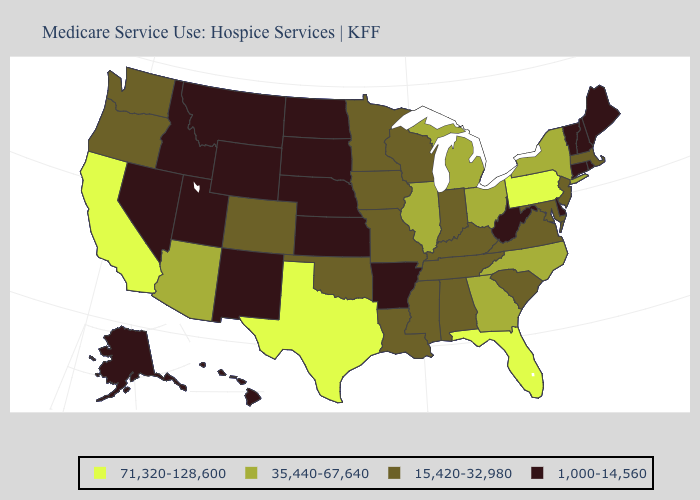Name the states that have a value in the range 1,000-14,560?
Write a very short answer. Alaska, Arkansas, Connecticut, Delaware, Hawaii, Idaho, Kansas, Maine, Montana, Nebraska, Nevada, New Hampshire, New Mexico, North Dakota, Rhode Island, South Dakota, Utah, Vermont, West Virginia, Wyoming. What is the highest value in the West ?
Be succinct. 71,320-128,600. Name the states that have a value in the range 1,000-14,560?
Be succinct. Alaska, Arkansas, Connecticut, Delaware, Hawaii, Idaho, Kansas, Maine, Montana, Nebraska, Nevada, New Hampshire, New Mexico, North Dakota, Rhode Island, South Dakota, Utah, Vermont, West Virginia, Wyoming. Does Florida have the highest value in the South?
Quick response, please. Yes. What is the value of Illinois?
Short answer required. 35,440-67,640. What is the value of New Mexico?
Short answer required. 1,000-14,560. Does the first symbol in the legend represent the smallest category?
Short answer required. No. Does Missouri have a higher value than California?
Be succinct. No. What is the lowest value in the USA?
Keep it brief. 1,000-14,560. What is the value of Hawaii?
Answer briefly. 1,000-14,560. Which states have the lowest value in the Northeast?
Keep it brief. Connecticut, Maine, New Hampshire, Rhode Island, Vermont. Is the legend a continuous bar?
Be succinct. No. What is the value of Wisconsin?
Keep it brief. 15,420-32,980. What is the lowest value in the USA?
Write a very short answer. 1,000-14,560. What is the value of Hawaii?
Keep it brief. 1,000-14,560. 